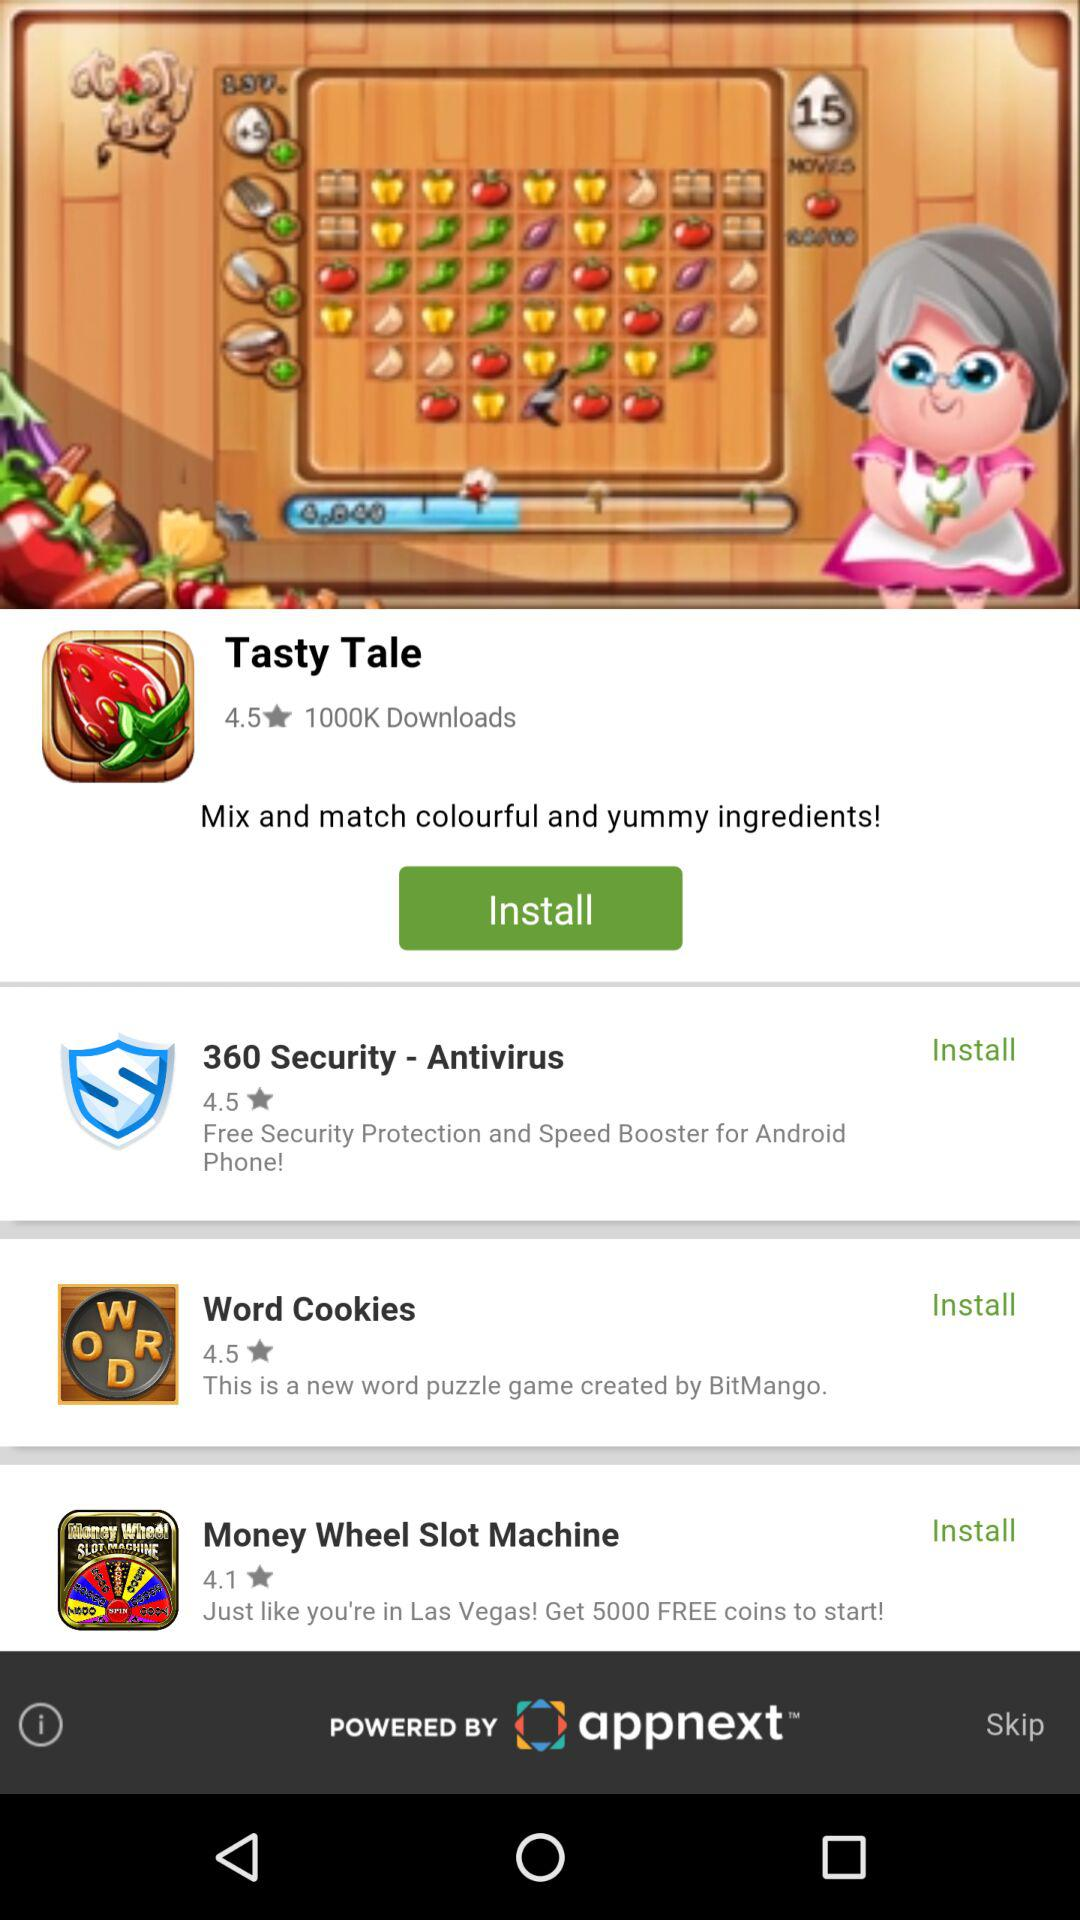How many games have a rating of 4.5 or higher?
Answer the question using a single word or phrase. 3 